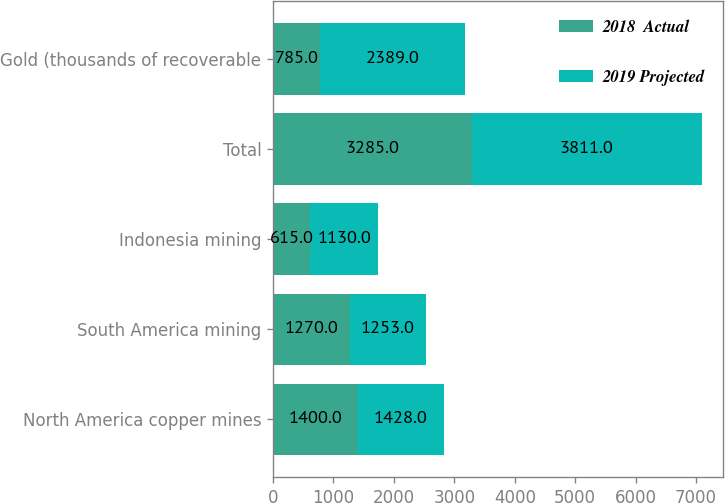Convert chart. <chart><loc_0><loc_0><loc_500><loc_500><stacked_bar_chart><ecel><fcel>North America copper mines<fcel>South America mining<fcel>Indonesia mining<fcel>Total<fcel>Gold (thousands of recoverable<nl><fcel>2018  Actual<fcel>1400<fcel>1270<fcel>615<fcel>3285<fcel>785<nl><fcel>2019 Projected<fcel>1428<fcel>1253<fcel>1130<fcel>3811<fcel>2389<nl></chart> 